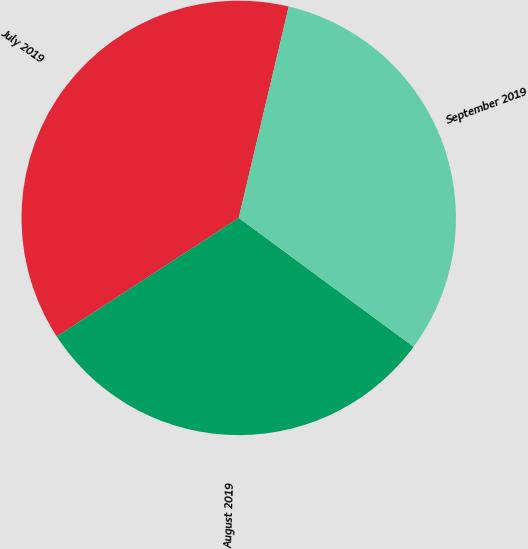<chart> <loc_0><loc_0><loc_500><loc_500><pie_chart><fcel>July 2019<fcel>August 2019<fcel>September 2019<nl><fcel>37.89%<fcel>30.7%<fcel>31.41%<nl></chart> 